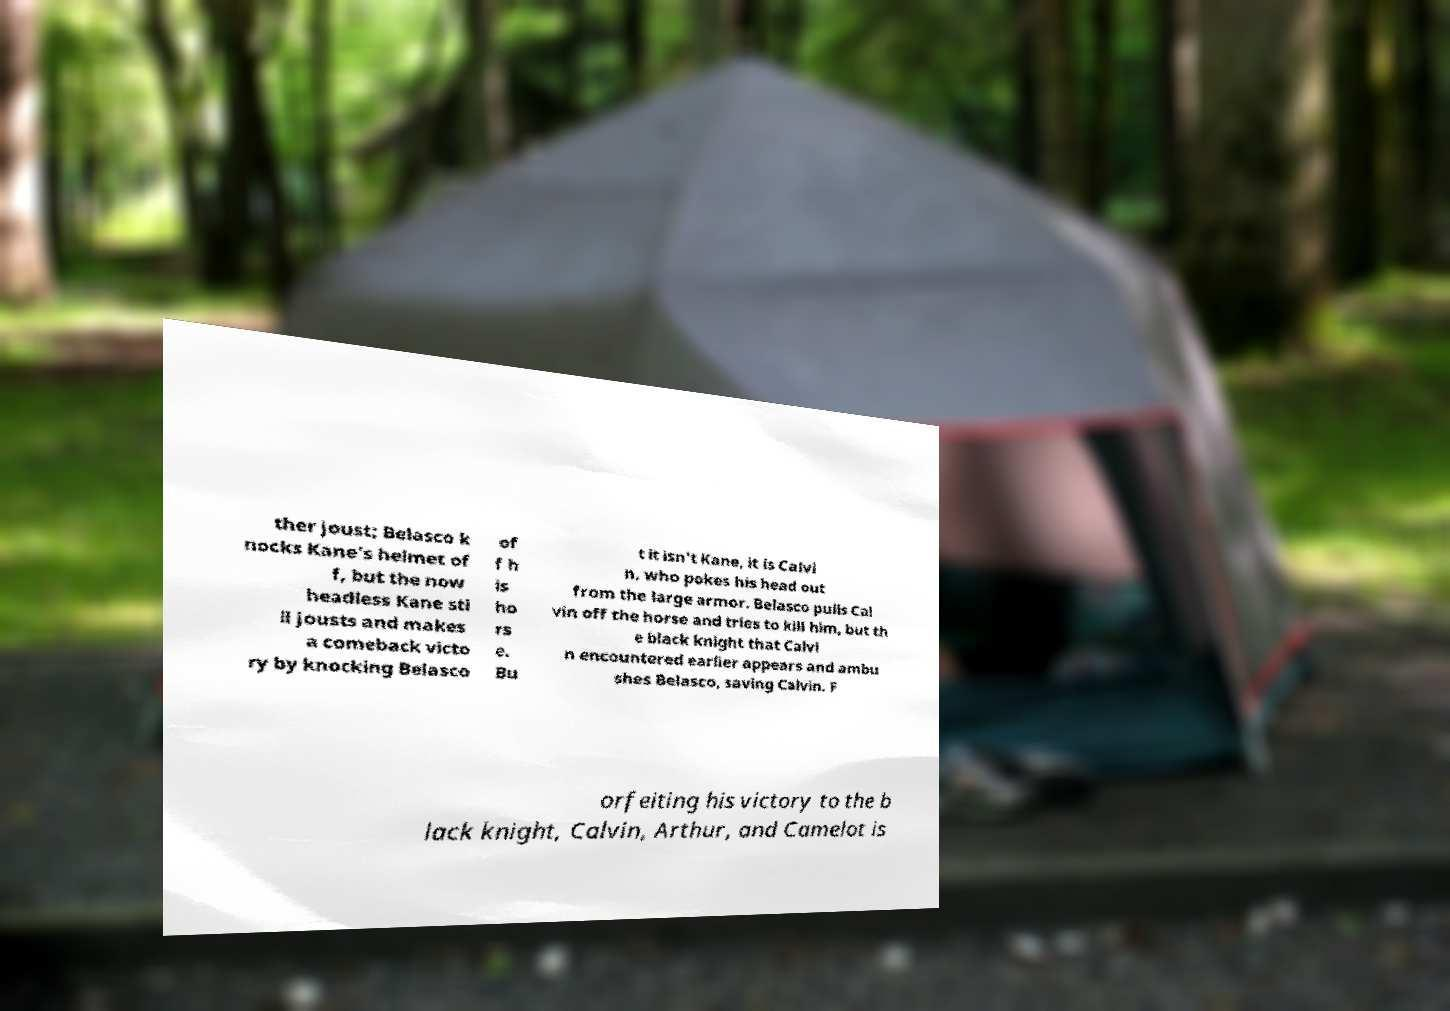Please identify and transcribe the text found in this image. ther joust; Belasco k nocks Kane's helmet of f, but the now headless Kane sti ll jousts and makes a comeback victo ry by knocking Belasco of f h is ho rs e. Bu t it isn't Kane, it is Calvi n, who pokes his head out from the large armor. Belasco pulls Cal vin off the horse and tries to kill him, but th e black knight that Calvi n encountered earlier appears and ambu shes Belasco, saving Calvin. F orfeiting his victory to the b lack knight, Calvin, Arthur, and Camelot is 